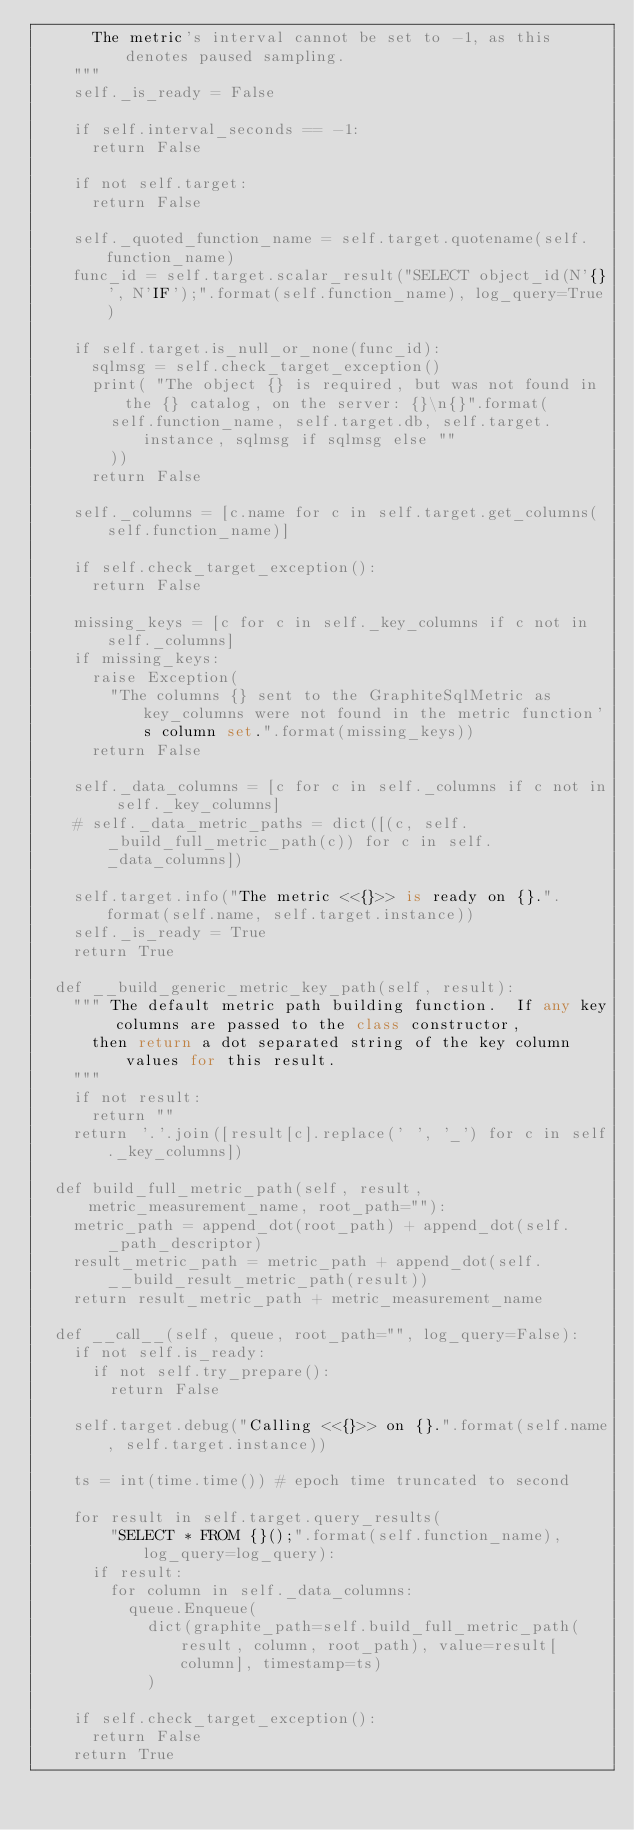<code> <loc_0><loc_0><loc_500><loc_500><_Python_>			The metric's interval cannot be set to -1, as this denotes paused sampling.
		"""
		self._is_ready = False

		if self.interval_seconds == -1:
			return False

		if not self.target:
			return False

		self._quoted_function_name = self.target.quotename(self.function_name)
		func_id = self.target.scalar_result("SELECT object_id(N'{}', N'IF');".format(self.function_name), log_query=True)

		if self.target.is_null_or_none(func_id):
			sqlmsg = self.check_target_exception()
			print( "The object {} is required, but was not found in the {} catalog, on the server: {}\n{}".format(
				self.function_name, self.target.db, self.target.instance, sqlmsg if sqlmsg else ""
				))
			return False

		self._columns = [c.name for c in self.target.get_columns(self.function_name)]

		if self.check_target_exception():
			return False

		missing_keys = [c for c in self._key_columns if c not in self._columns]
		if missing_keys:
			raise Exception(
				"The columns {} sent to the GraphiteSqlMetric as key_columns were not found in the metric function's column set.".format(missing_keys))
			return False

		self._data_columns = [c for c in self._columns if c not in self._key_columns]
		# self._data_metric_paths = dict([(c, self._build_full_metric_path(c)) for c in self._data_columns])

		self.target.info("The metric <<{}>> is ready on {}.".format(self.name, self.target.instance))
		self._is_ready = True
		return True

	def __build_generic_metric_key_path(self, result):
		""" The default metric path building function.  If any key columns are passed to the class constructor, 
			then return a dot separated string of the key column values for this result.
		"""
		if not result:
			return ""
		return '.'.join([result[c].replace(' ', '_') for c in self._key_columns])

	def build_full_metric_path(self, result, metric_measurement_name, root_path=""):
		metric_path = append_dot(root_path) + append_dot(self._path_descriptor)
		result_metric_path = metric_path + append_dot(self.__build_result_metric_path(result))
		return result_metric_path + metric_measurement_name

	def __call__(self, queue, root_path="", log_query=False):
		if not self.is_ready:
			if not self.try_prepare():
				return False

		self.target.debug("Calling <<{}>> on {}.".format(self.name, self.target.instance))

		ts = int(time.time())	# epoch time truncated to second

		for result in self.target.query_results(
				"SELECT * FROM {}();".format(self.function_name), log_query=log_query):
			if result:
				for column in self._data_columns:
					queue.Enqueue(
						dict(graphite_path=self.build_full_metric_path(result, column, root_path), value=result[column], timestamp=ts)
						)

		if self.check_target_exception():
			return False
		return True
</code> 